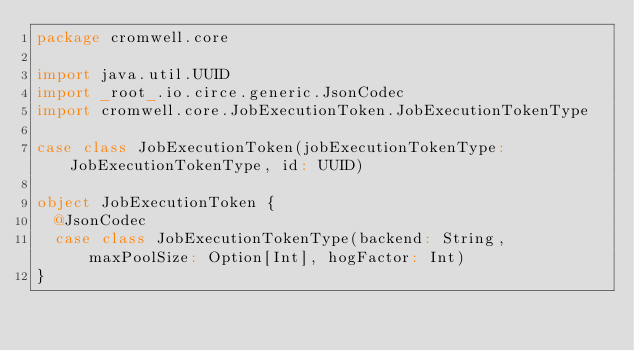<code> <loc_0><loc_0><loc_500><loc_500><_Scala_>package cromwell.core

import java.util.UUID
import _root_.io.circe.generic.JsonCodec
import cromwell.core.JobExecutionToken.JobExecutionTokenType

case class JobExecutionToken(jobExecutionTokenType: JobExecutionTokenType, id: UUID)

object JobExecutionToken {
  @JsonCodec
  case class JobExecutionTokenType(backend: String, maxPoolSize: Option[Int], hogFactor: Int)
}
</code> 